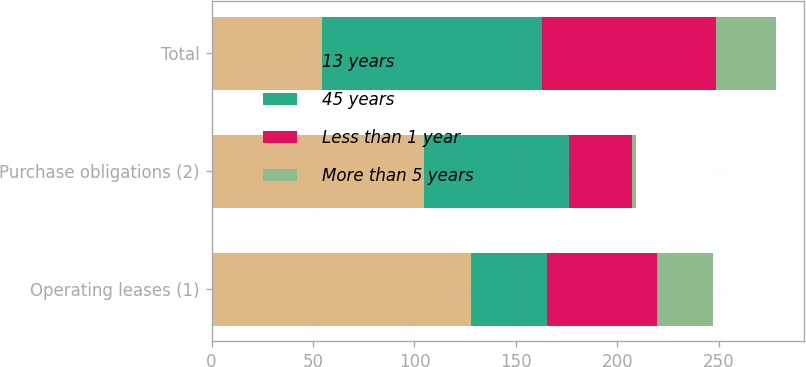Convert chart to OTSL. <chart><loc_0><loc_0><loc_500><loc_500><stacked_bar_chart><ecel><fcel>Operating leases (1)<fcel>Purchase obligations (2)<fcel>Total<nl><fcel>13 years<fcel>127.7<fcel>104.8<fcel>54.3<nl><fcel>45 years<fcel>37.5<fcel>71.2<fcel>108.7<nl><fcel>Less than 1 year<fcel>54.3<fcel>31.2<fcel>85.5<nl><fcel>More than 5 years<fcel>27.4<fcel>2.2<fcel>29.6<nl></chart> 